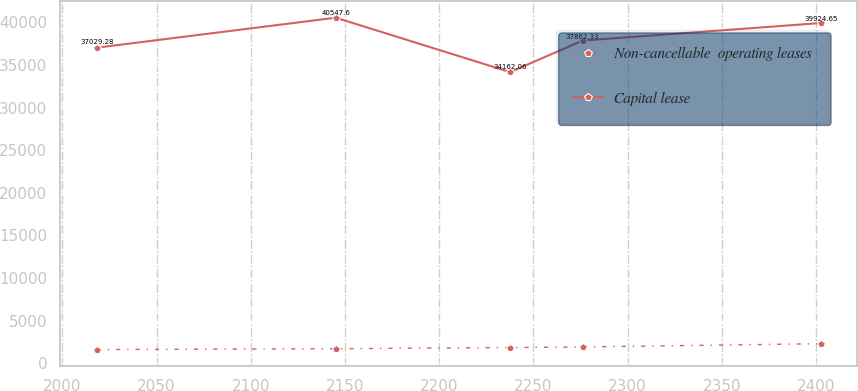<chart> <loc_0><loc_0><loc_500><loc_500><line_chart><ecel><fcel>Non-cancellable  operating leases<fcel>Capital lease<nl><fcel>2018.19<fcel>1597.78<fcel>37029.3<nl><fcel>2145.12<fcel>1699.23<fcel>40547.6<nl><fcel>2237.65<fcel>1833.78<fcel>34162.1<nl><fcel>2276.1<fcel>1902.87<fcel>37862.3<nl><fcel>2402.68<fcel>2288.69<fcel>39924.7<nl></chart> 